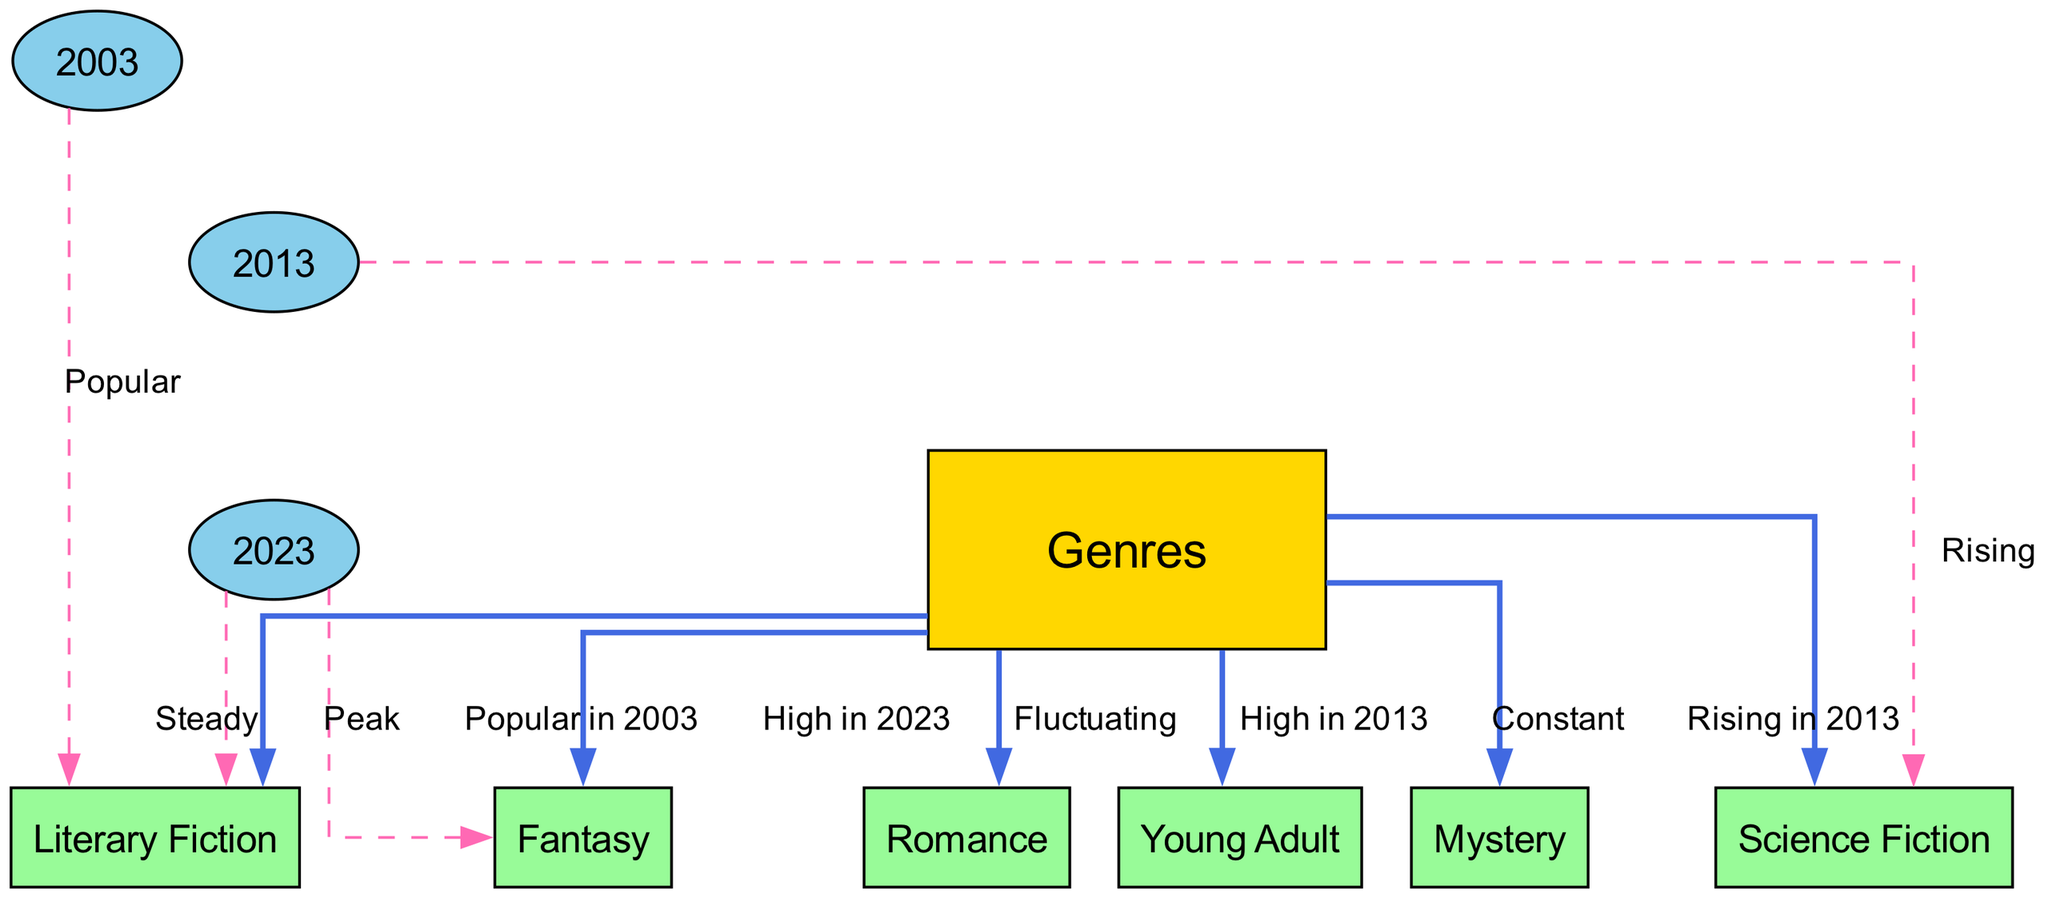What genre was popular in 2003? The diagram shows an edge from the "Genres" node to "Literary Fiction," labeled "Popular in 2003." This indicates that Literary Fiction was the genre popular at that time.
Answer: Literary Fiction Which genre has been constant over the two decades? The edge from "Genres" to "Mystery" is labeled "Constant," indicating that the Mystery genre has maintained its popularity throughout the two decades without significant changes.
Answer: Constant What genre peaked in 2023? According to the diagram, the edge from "2023" to "Fantasy" is labeled "Peak," indicating that Fantasy reached its highest popularity that year.
Answer: Peak Which genre showed a rise in popularity between 2013 and 2023? The edge from "2013" to "Fantasy" shows a relationship labeled "High in 2023," suggesting a rising popularity for Fantasy between those years.
Answer: Fantasy How many literary genres are represented in the diagram? By counting the genre nodes connected to the "Genres" node, there are six literary genres represented: Literary Fiction, Science Fiction, Fantasy, Mystery, Romance, and Young Adult.
Answer: Six Which genre showed fluctuating popularity metrics? The edge labeled "Fluctuating" connects "Genres" to "Romance," indicating this genre experienced variable popularity metrics over the years.
Answer: Fluctuating What is the relationship between Science Fiction and the year 2013? The edge from "2013" to "Science Fiction" is labeled "Rising," showing that Science Fiction's popularity was increasing during that year.
Answer: Rising Which two genres had high popularity in 2013? The diagram shows edges to both "Science Fiction" and "Young Adult," and both are labeled "Rising in 2013" and "High in 2013," respectively, indicating their increased popularity during that time.
Answer: Science Fiction and Young Adult 